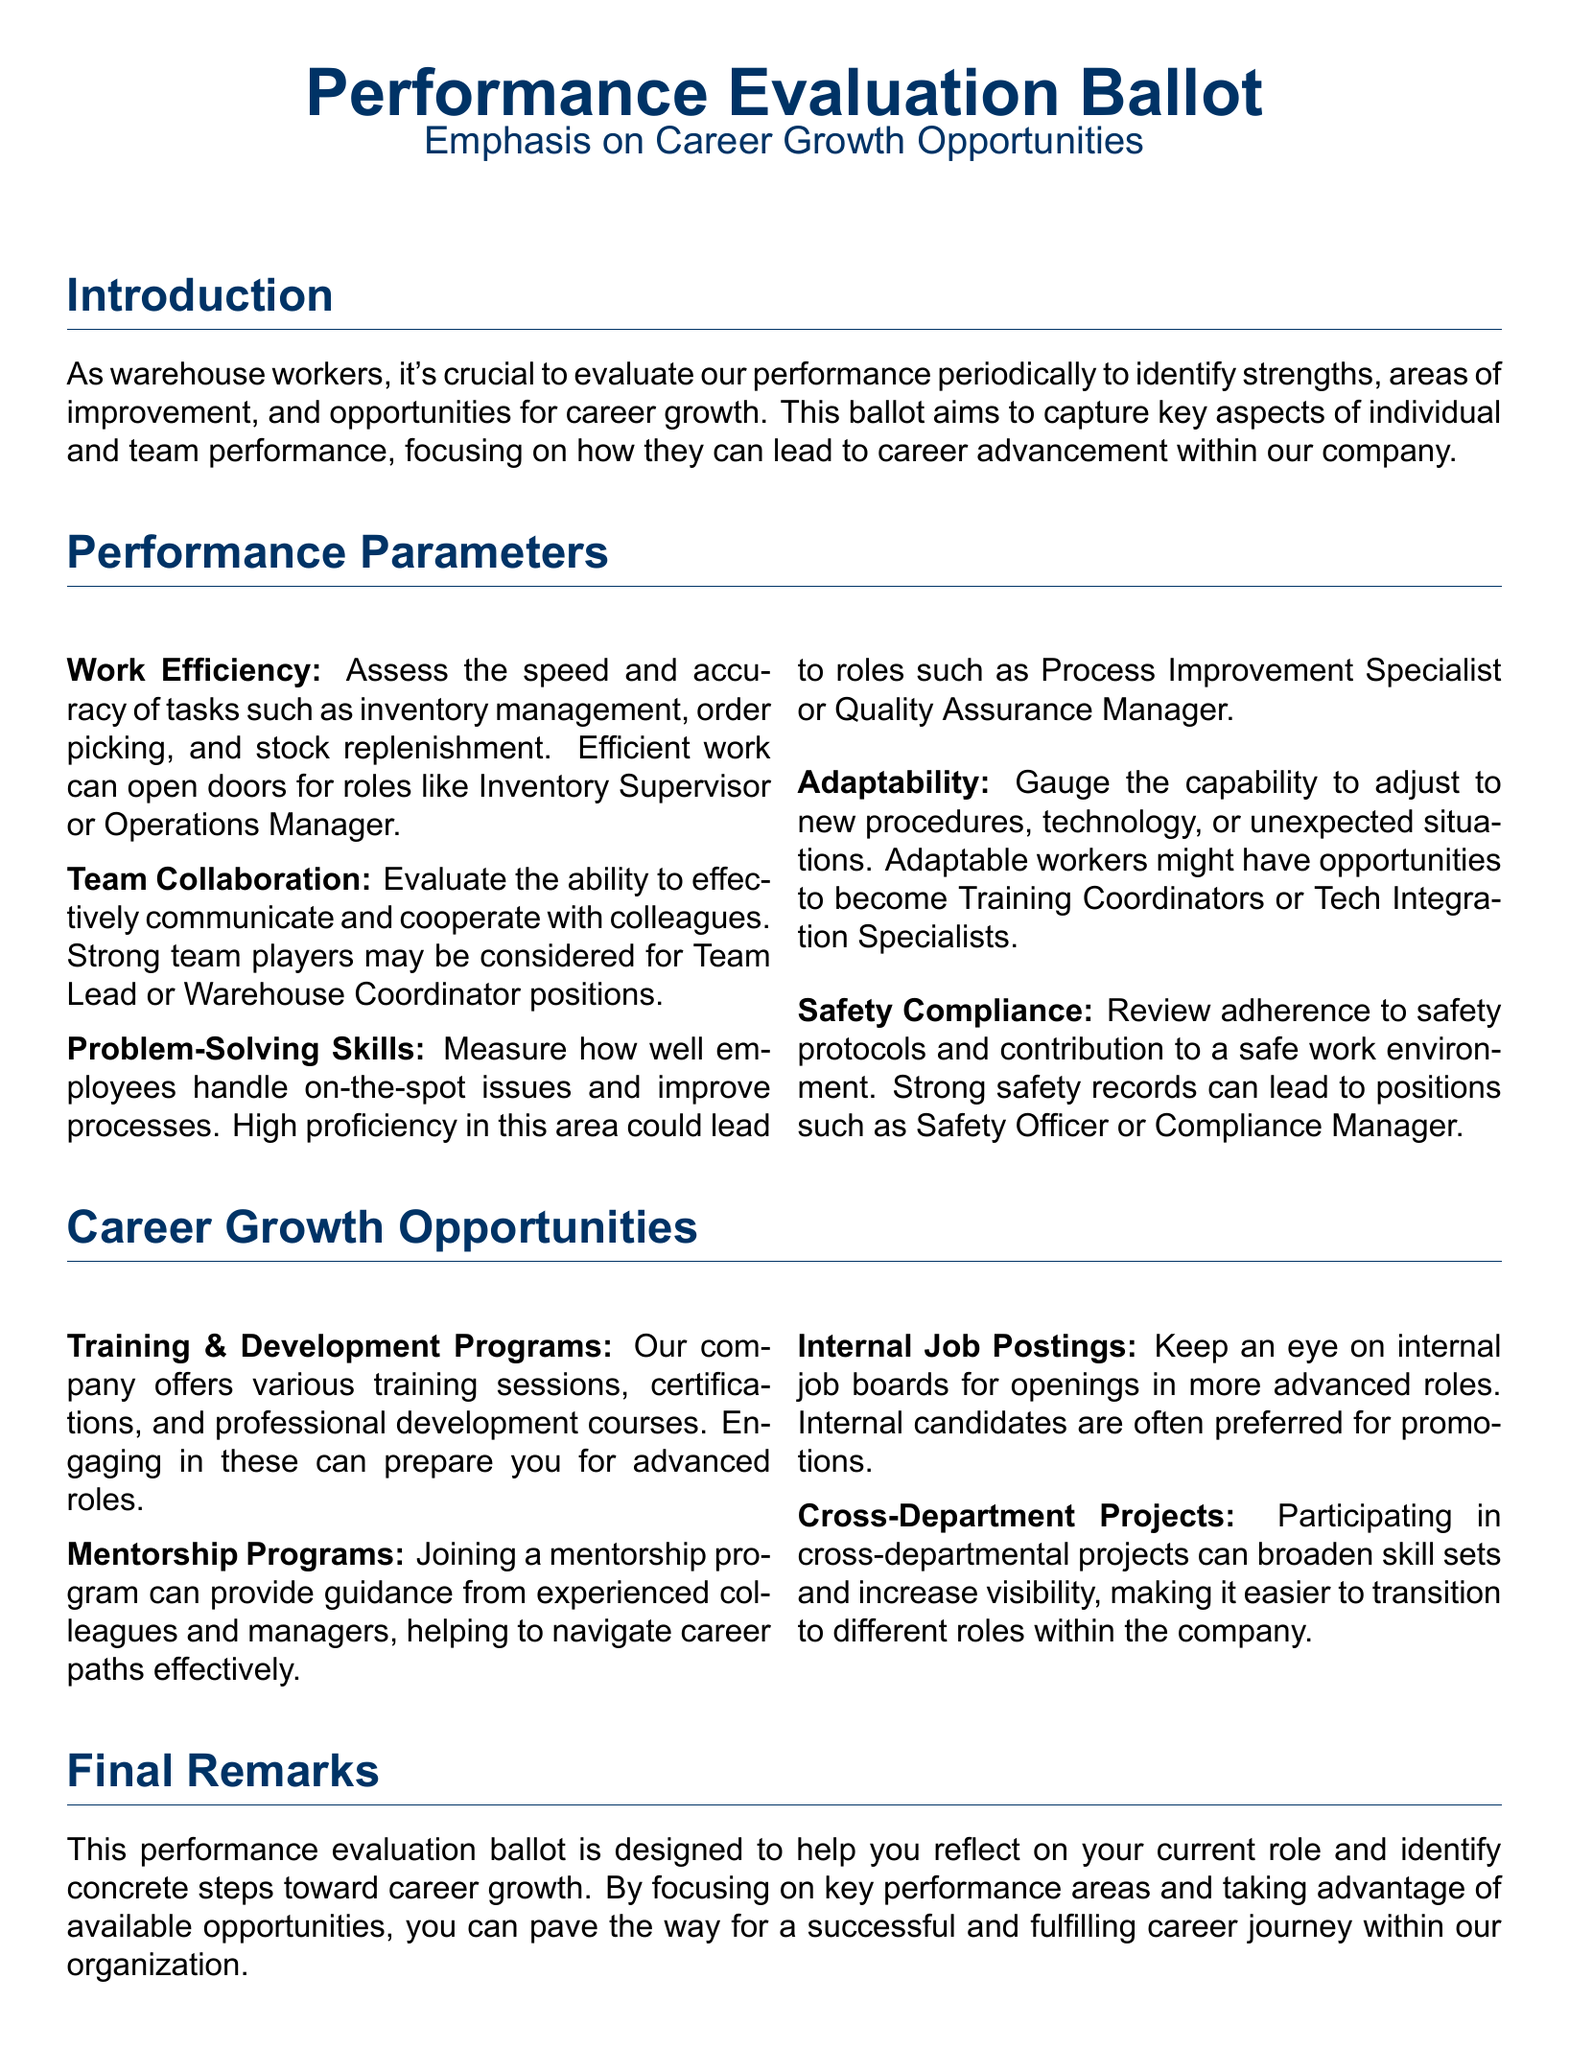What is the main focus of the performance evaluation ballot? The main focus is to evaluate strengths, areas of improvement, and opportunities for career growth.
Answer: career growth opportunities How many performance parameters are listed in the document? The number of performance parameters can be counted in the document under the Performance Parameters section.
Answer: five What role could high proficiency in problem-solving skills lead to? The document states that high proficiency in problem-solving could lead to a specific role mentioned under Problem-Solving Skills.
Answer: Process Improvement Specialist What is one opportunity for career growth mentioned? The document lists specific opportunities, one of which can be directly quoted under Career Growth Opportunities.
Answer: Training & Development Programs Which position might be offered to strong team players? The document indicates a particular position that might be available to individuals who excel in team collaboration.
Answer: Team Lead 